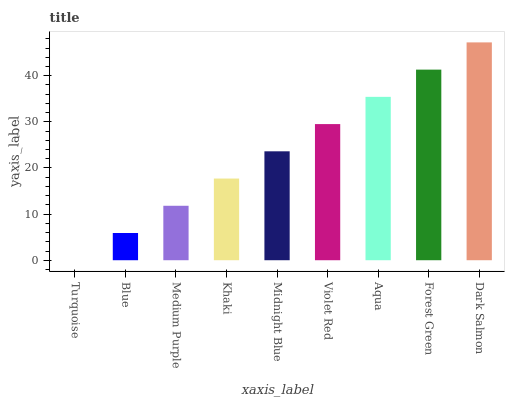Is Turquoise the minimum?
Answer yes or no. Yes. Is Dark Salmon the maximum?
Answer yes or no. Yes. Is Blue the minimum?
Answer yes or no. No. Is Blue the maximum?
Answer yes or no. No. Is Blue greater than Turquoise?
Answer yes or no. Yes. Is Turquoise less than Blue?
Answer yes or no. Yes. Is Turquoise greater than Blue?
Answer yes or no. No. Is Blue less than Turquoise?
Answer yes or no. No. Is Midnight Blue the high median?
Answer yes or no. Yes. Is Midnight Blue the low median?
Answer yes or no. Yes. Is Turquoise the high median?
Answer yes or no. No. Is Blue the low median?
Answer yes or no. No. 